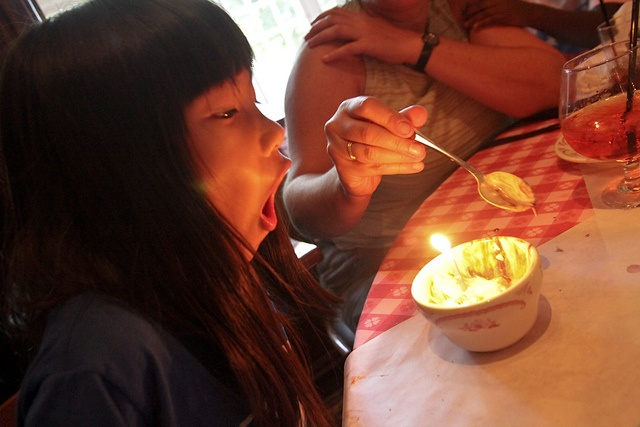Describe the objects in this image and their specific colors. I can see people in black, maroon, red, and brown tones, dining table in black, tan, salmon, red, and brown tones, people in black, maroon, and brown tones, bowl in black, brown, lightyellow, and khaki tones, and wine glass in black, brown, and maroon tones in this image. 